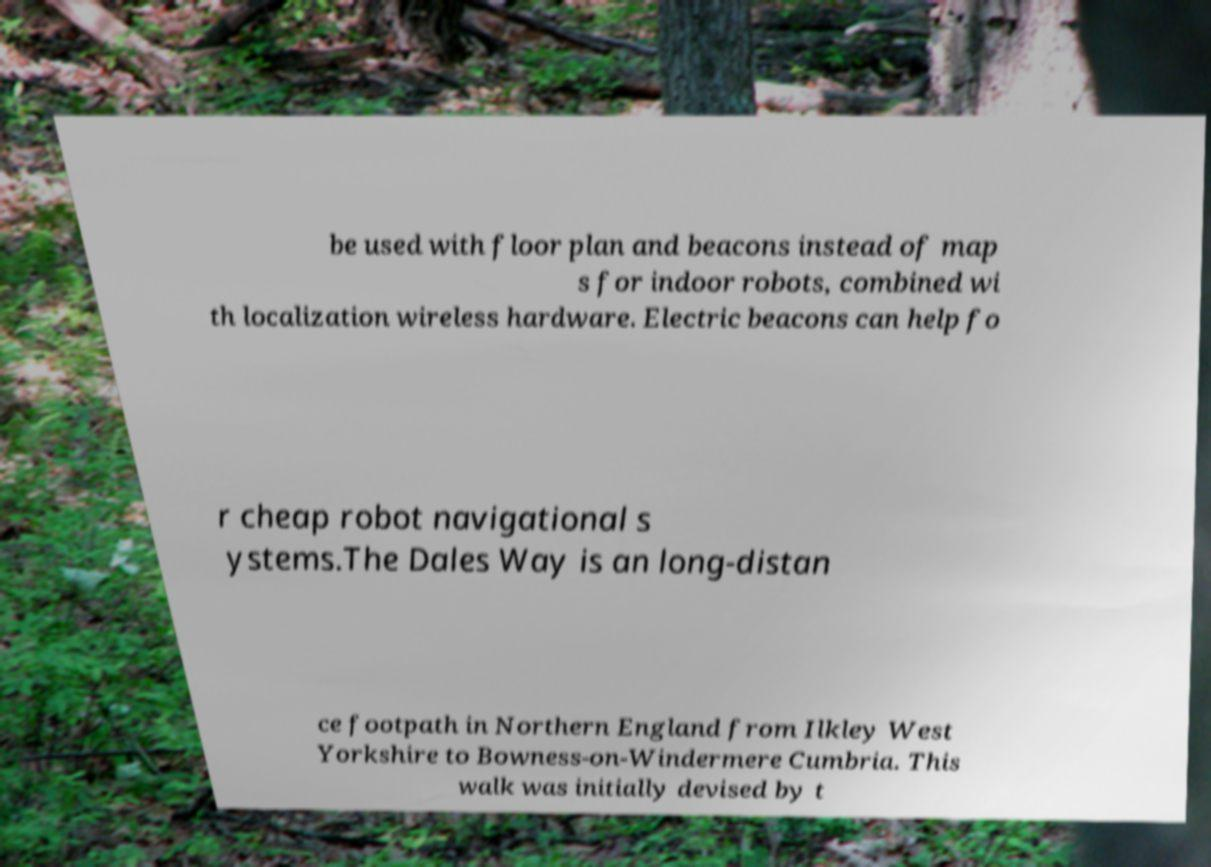Could you assist in decoding the text presented in this image and type it out clearly? be used with floor plan and beacons instead of map s for indoor robots, combined wi th localization wireless hardware. Electric beacons can help fo r cheap robot navigational s ystems.The Dales Way is an long-distan ce footpath in Northern England from Ilkley West Yorkshire to Bowness-on-Windermere Cumbria. This walk was initially devised by t 